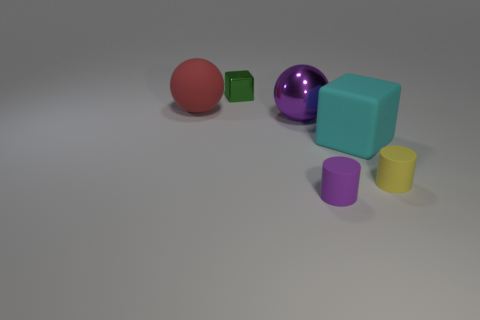How many matte things have the same color as the metal sphere?
Ensure brevity in your answer.  1. Is the color of the shiny sphere that is behind the small purple rubber cylinder the same as the small matte cylinder that is to the left of the cyan cube?
Your response must be concise. Yes. Do the purple thing that is in front of the small yellow rubber object and the large purple object have the same material?
Offer a terse response. No. Do the purple ball and the purple cylinder have the same material?
Your answer should be very brief. No. What number of other objects are the same color as the large metal object?
Offer a very short reply. 1. Are there any other rubber things of the same size as the green thing?
Keep it short and to the point. Yes. There is a red sphere that is the same size as the cyan rubber thing; what material is it?
Offer a terse response. Rubber. Is the size of the red matte object the same as the purple thing that is in front of the large cyan block?
Make the answer very short. No. What number of metal objects are large brown blocks or large purple spheres?
Your answer should be compact. 1. What number of red things have the same shape as the large cyan thing?
Offer a terse response. 0. 